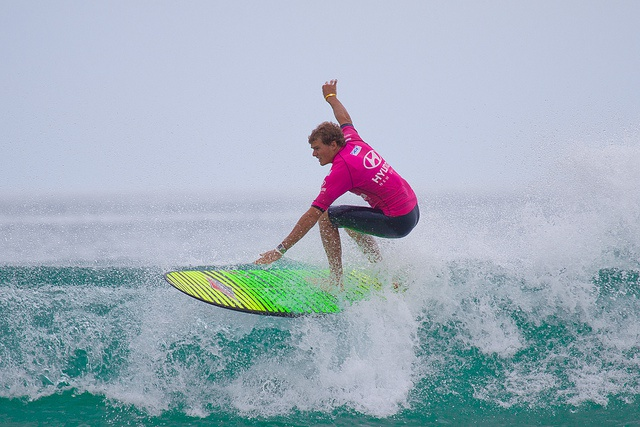Describe the objects in this image and their specific colors. I can see people in lightgray, purple, darkgray, gray, and black tones and surfboard in lavender, darkgray, teal, yellow, and lightgreen tones in this image. 